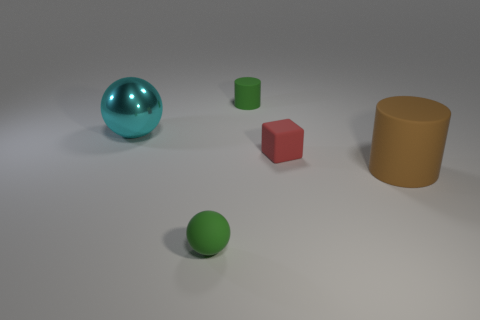Is the number of large brown rubber things less than the number of green matte things?
Your answer should be compact. Yes. Are there any tiny brown matte objects?
Make the answer very short. No. How many other things are the same size as the rubber block?
Give a very brief answer. 2. Are the brown cylinder and the ball on the left side of the small rubber sphere made of the same material?
Offer a terse response. No. Is the number of small red rubber objects that are on the left side of the cyan object the same as the number of matte cubes to the right of the red rubber thing?
Ensure brevity in your answer.  Yes. What is the tiny red object made of?
Ensure brevity in your answer.  Rubber. What color is the other thing that is the same size as the brown object?
Give a very brief answer. Cyan. There is a green matte thing behind the green sphere; is there a tiny green rubber sphere that is right of it?
Your answer should be very brief. No. What number of cylinders are either red objects or small matte things?
Provide a short and direct response. 1. What is the size of the green rubber thing right of the ball in front of the cylinder in front of the tiny red object?
Offer a terse response. Small. 